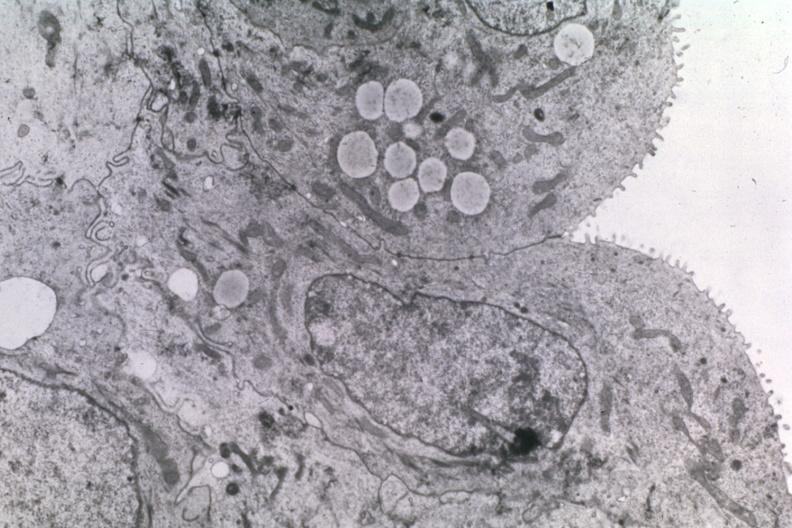what is present?
Answer the question using a single word or phrase. Brain 